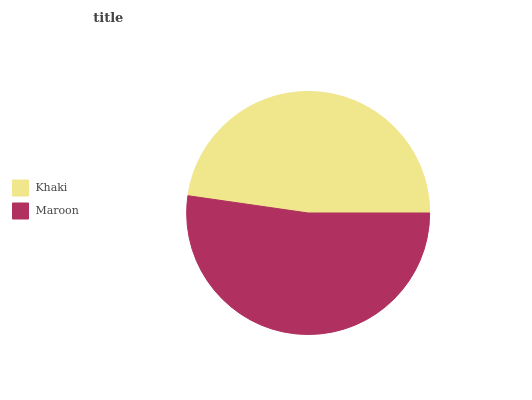Is Khaki the minimum?
Answer yes or no. Yes. Is Maroon the maximum?
Answer yes or no. Yes. Is Maroon the minimum?
Answer yes or no. No. Is Maroon greater than Khaki?
Answer yes or no. Yes. Is Khaki less than Maroon?
Answer yes or no. Yes. Is Khaki greater than Maroon?
Answer yes or no. No. Is Maroon less than Khaki?
Answer yes or no. No. Is Maroon the high median?
Answer yes or no. Yes. Is Khaki the low median?
Answer yes or no. Yes. Is Khaki the high median?
Answer yes or no. No. Is Maroon the low median?
Answer yes or no. No. 